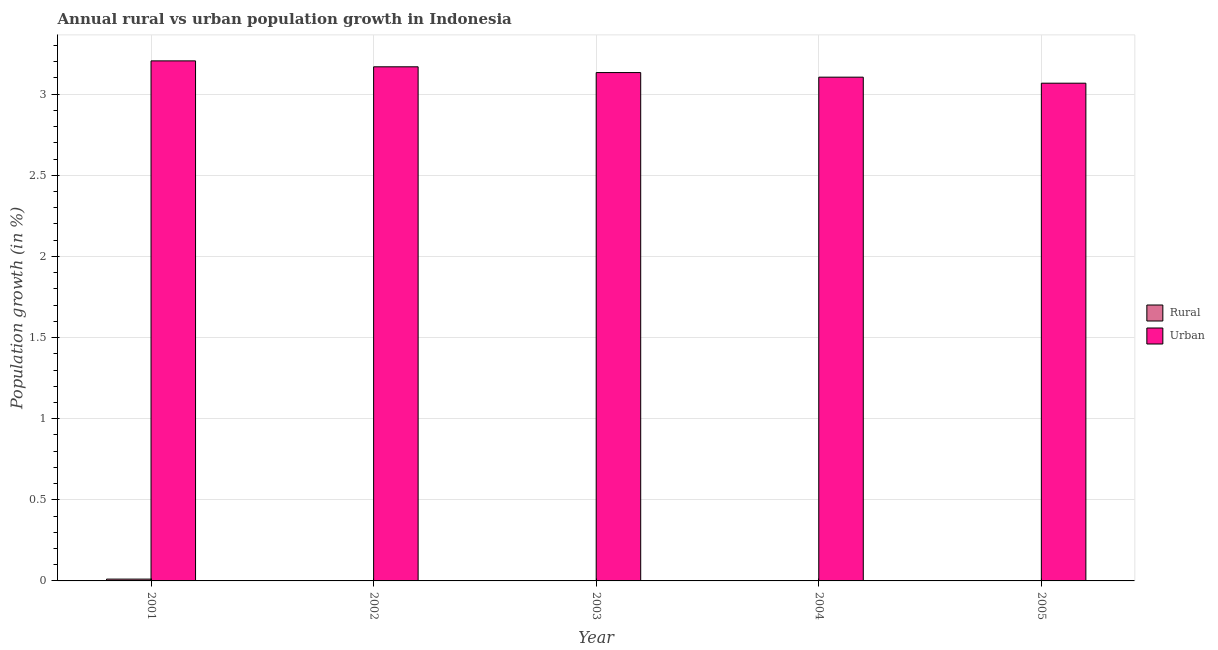How many different coloured bars are there?
Offer a very short reply. 2. How many bars are there on the 1st tick from the left?
Provide a short and direct response. 2. What is the urban population growth in 2001?
Provide a succinct answer. 3.21. Across all years, what is the maximum rural population growth?
Your answer should be very brief. 0.01. Across all years, what is the minimum urban population growth?
Provide a short and direct response. 3.07. In which year was the urban population growth maximum?
Make the answer very short. 2001. What is the total rural population growth in the graph?
Provide a short and direct response. 0.01. What is the difference between the urban population growth in 2001 and that in 2002?
Provide a succinct answer. 0.04. What is the difference between the rural population growth in 2001 and the urban population growth in 2002?
Offer a terse response. 0.01. What is the average rural population growth per year?
Make the answer very short. 0. In how many years, is the rural population growth greater than 1.2 %?
Make the answer very short. 0. What is the ratio of the urban population growth in 2001 to that in 2003?
Provide a succinct answer. 1.02. Is the urban population growth in 2001 less than that in 2003?
Your answer should be very brief. No. What is the difference between the highest and the second highest urban population growth?
Make the answer very short. 0.04. What is the difference between the highest and the lowest rural population growth?
Offer a terse response. 0.01. In how many years, is the urban population growth greater than the average urban population growth taken over all years?
Offer a very short reply. 2. Is the sum of the urban population growth in 2001 and 2003 greater than the maximum rural population growth across all years?
Make the answer very short. Yes. How many bars are there?
Give a very brief answer. 6. Are all the bars in the graph horizontal?
Ensure brevity in your answer.  No. What is the difference between two consecutive major ticks on the Y-axis?
Ensure brevity in your answer.  0.5. Are the values on the major ticks of Y-axis written in scientific E-notation?
Your answer should be compact. No. Where does the legend appear in the graph?
Your answer should be compact. Center right. What is the title of the graph?
Make the answer very short. Annual rural vs urban population growth in Indonesia. What is the label or title of the Y-axis?
Your answer should be compact. Population growth (in %). What is the Population growth (in %) of Rural in 2001?
Ensure brevity in your answer.  0.01. What is the Population growth (in %) in Urban  in 2001?
Your response must be concise. 3.21. What is the Population growth (in %) in Rural in 2002?
Ensure brevity in your answer.  0. What is the Population growth (in %) in Urban  in 2002?
Your answer should be compact. 3.17. What is the Population growth (in %) in Urban  in 2003?
Your answer should be very brief. 3.13. What is the Population growth (in %) in Urban  in 2004?
Give a very brief answer. 3.1. What is the Population growth (in %) in Rural in 2005?
Provide a succinct answer. 0. What is the Population growth (in %) of Urban  in 2005?
Offer a terse response. 3.07. Across all years, what is the maximum Population growth (in %) in Rural?
Give a very brief answer. 0.01. Across all years, what is the maximum Population growth (in %) in Urban ?
Offer a very short reply. 3.21. Across all years, what is the minimum Population growth (in %) of Urban ?
Ensure brevity in your answer.  3.07. What is the total Population growth (in %) in Rural in the graph?
Ensure brevity in your answer.  0.01. What is the total Population growth (in %) of Urban  in the graph?
Provide a short and direct response. 15.68. What is the difference between the Population growth (in %) in Urban  in 2001 and that in 2002?
Your answer should be very brief. 0.04. What is the difference between the Population growth (in %) of Urban  in 2001 and that in 2003?
Ensure brevity in your answer.  0.07. What is the difference between the Population growth (in %) in Urban  in 2001 and that in 2004?
Your response must be concise. 0.1. What is the difference between the Population growth (in %) of Urban  in 2001 and that in 2005?
Offer a terse response. 0.14. What is the difference between the Population growth (in %) in Urban  in 2002 and that in 2003?
Ensure brevity in your answer.  0.04. What is the difference between the Population growth (in %) of Urban  in 2002 and that in 2004?
Provide a short and direct response. 0.06. What is the difference between the Population growth (in %) of Urban  in 2002 and that in 2005?
Provide a succinct answer. 0.1. What is the difference between the Population growth (in %) in Urban  in 2003 and that in 2004?
Make the answer very short. 0.03. What is the difference between the Population growth (in %) of Urban  in 2003 and that in 2005?
Your answer should be compact. 0.07. What is the difference between the Population growth (in %) in Urban  in 2004 and that in 2005?
Your response must be concise. 0.04. What is the difference between the Population growth (in %) of Rural in 2001 and the Population growth (in %) of Urban  in 2002?
Give a very brief answer. -3.16. What is the difference between the Population growth (in %) in Rural in 2001 and the Population growth (in %) in Urban  in 2003?
Your answer should be compact. -3.12. What is the difference between the Population growth (in %) of Rural in 2001 and the Population growth (in %) of Urban  in 2004?
Keep it short and to the point. -3.09. What is the difference between the Population growth (in %) of Rural in 2001 and the Population growth (in %) of Urban  in 2005?
Provide a succinct answer. -3.06. What is the average Population growth (in %) of Rural per year?
Offer a very short reply. 0. What is the average Population growth (in %) of Urban  per year?
Your response must be concise. 3.14. In the year 2001, what is the difference between the Population growth (in %) in Rural and Population growth (in %) in Urban ?
Provide a short and direct response. -3.19. What is the ratio of the Population growth (in %) in Urban  in 2001 to that in 2002?
Offer a very short reply. 1.01. What is the ratio of the Population growth (in %) of Urban  in 2001 to that in 2003?
Your response must be concise. 1.02. What is the ratio of the Population growth (in %) of Urban  in 2001 to that in 2004?
Your response must be concise. 1.03. What is the ratio of the Population growth (in %) of Urban  in 2001 to that in 2005?
Offer a terse response. 1.04. What is the ratio of the Population growth (in %) in Urban  in 2002 to that in 2003?
Offer a very short reply. 1.01. What is the ratio of the Population growth (in %) of Urban  in 2002 to that in 2004?
Offer a very short reply. 1.02. What is the ratio of the Population growth (in %) of Urban  in 2002 to that in 2005?
Your answer should be very brief. 1.03. What is the ratio of the Population growth (in %) in Urban  in 2003 to that in 2004?
Offer a terse response. 1.01. What is the ratio of the Population growth (in %) of Urban  in 2003 to that in 2005?
Your response must be concise. 1.02. What is the ratio of the Population growth (in %) in Urban  in 2004 to that in 2005?
Keep it short and to the point. 1.01. What is the difference between the highest and the second highest Population growth (in %) of Urban ?
Your answer should be compact. 0.04. What is the difference between the highest and the lowest Population growth (in %) in Rural?
Offer a terse response. 0.01. What is the difference between the highest and the lowest Population growth (in %) in Urban ?
Offer a terse response. 0.14. 